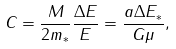<formula> <loc_0><loc_0><loc_500><loc_500>C = \frac { M } { 2 m _ { * } } \frac { \Delta E } { E } = \frac { a \Delta E _ { * } } { G \mu } ,</formula> 